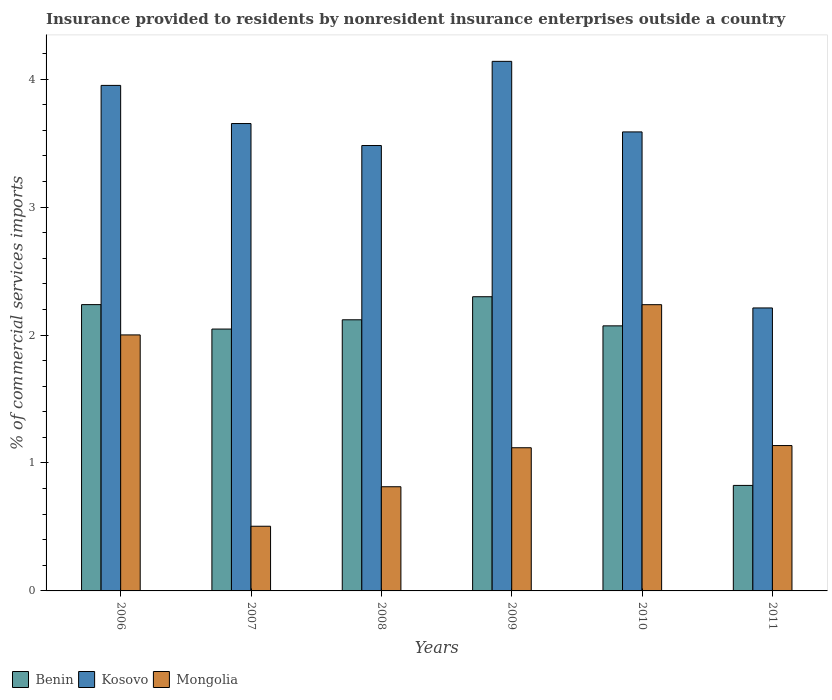Are the number of bars per tick equal to the number of legend labels?
Ensure brevity in your answer.  Yes. Are the number of bars on each tick of the X-axis equal?
Your answer should be compact. Yes. How many bars are there on the 1st tick from the left?
Your response must be concise. 3. What is the label of the 5th group of bars from the left?
Ensure brevity in your answer.  2010. What is the Insurance provided to residents in Benin in 2010?
Ensure brevity in your answer.  2.07. Across all years, what is the maximum Insurance provided to residents in Mongolia?
Offer a terse response. 2.24. Across all years, what is the minimum Insurance provided to residents in Kosovo?
Your response must be concise. 2.21. In which year was the Insurance provided to residents in Mongolia maximum?
Give a very brief answer. 2010. In which year was the Insurance provided to residents in Benin minimum?
Keep it short and to the point. 2011. What is the total Insurance provided to residents in Kosovo in the graph?
Your answer should be compact. 21.02. What is the difference between the Insurance provided to residents in Mongolia in 2007 and that in 2009?
Keep it short and to the point. -0.61. What is the difference between the Insurance provided to residents in Benin in 2011 and the Insurance provided to residents in Mongolia in 2006?
Ensure brevity in your answer.  -1.18. What is the average Insurance provided to residents in Kosovo per year?
Provide a succinct answer. 3.5. In the year 2006, what is the difference between the Insurance provided to residents in Kosovo and Insurance provided to residents in Benin?
Provide a succinct answer. 1.71. What is the ratio of the Insurance provided to residents in Kosovo in 2006 to that in 2009?
Offer a terse response. 0.95. Is the Insurance provided to residents in Kosovo in 2009 less than that in 2011?
Your response must be concise. No. What is the difference between the highest and the second highest Insurance provided to residents in Benin?
Provide a short and direct response. 0.06. What is the difference between the highest and the lowest Insurance provided to residents in Kosovo?
Give a very brief answer. 1.93. Is the sum of the Insurance provided to residents in Kosovo in 2007 and 2009 greater than the maximum Insurance provided to residents in Benin across all years?
Give a very brief answer. Yes. What does the 2nd bar from the left in 2009 represents?
Your response must be concise. Kosovo. What does the 3rd bar from the right in 2008 represents?
Provide a succinct answer. Benin. Is it the case that in every year, the sum of the Insurance provided to residents in Kosovo and Insurance provided to residents in Mongolia is greater than the Insurance provided to residents in Benin?
Provide a short and direct response. Yes. How many years are there in the graph?
Your response must be concise. 6. Are the values on the major ticks of Y-axis written in scientific E-notation?
Provide a short and direct response. No. Where does the legend appear in the graph?
Offer a very short reply. Bottom left. How many legend labels are there?
Give a very brief answer. 3. What is the title of the graph?
Make the answer very short. Insurance provided to residents by nonresident insurance enterprises outside a country. What is the label or title of the Y-axis?
Your answer should be compact. % of commercial services imports. What is the % of commercial services imports of Benin in 2006?
Offer a terse response. 2.24. What is the % of commercial services imports of Kosovo in 2006?
Give a very brief answer. 3.95. What is the % of commercial services imports in Mongolia in 2006?
Ensure brevity in your answer.  2. What is the % of commercial services imports of Benin in 2007?
Your answer should be very brief. 2.05. What is the % of commercial services imports of Kosovo in 2007?
Offer a very short reply. 3.65. What is the % of commercial services imports in Mongolia in 2007?
Offer a terse response. 0.51. What is the % of commercial services imports of Benin in 2008?
Your answer should be compact. 2.12. What is the % of commercial services imports in Kosovo in 2008?
Make the answer very short. 3.48. What is the % of commercial services imports in Mongolia in 2008?
Your answer should be compact. 0.81. What is the % of commercial services imports of Benin in 2009?
Your answer should be very brief. 2.3. What is the % of commercial services imports of Kosovo in 2009?
Make the answer very short. 4.14. What is the % of commercial services imports in Mongolia in 2009?
Provide a succinct answer. 1.12. What is the % of commercial services imports in Benin in 2010?
Your answer should be very brief. 2.07. What is the % of commercial services imports of Kosovo in 2010?
Offer a terse response. 3.59. What is the % of commercial services imports of Mongolia in 2010?
Your answer should be very brief. 2.24. What is the % of commercial services imports of Benin in 2011?
Provide a succinct answer. 0.82. What is the % of commercial services imports in Kosovo in 2011?
Your response must be concise. 2.21. What is the % of commercial services imports in Mongolia in 2011?
Provide a succinct answer. 1.14. Across all years, what is the maximum % of commercial services imports in Benin?
Your response must be concise. 2.3. Across all years, what is the maximum % of commercial services imports in Kosovo?
Your answer should be compact. 4.14. Across all years, what is the maximum % of commercial services imports in Mongolia?
Your answer should be compact. 2.24. Across all years, what is the minimum % of commercial services imports in Benin?
Your answer should be compact. 0.82. Across all years, what is the minimum % of commercial services imports of Kosovo?
Keep it short and to the point. 2.21. Across all years, what is the minimum % of commercial services imports in Mongolia?
Offer a very short reply. 0.51. What is the total % of commercial services imports of Benin in the graph?
Provide a succinct answer. 11.6. What is the total % of commercial services imports in Kosovo in the graph?
Your answer should be very brief. 21.02. What is the total % of commercial services imports of Mongolia in the graph?
Provide a short and direct response. 7.81. What is the difference between the % of commercial services imports of Benin in 2006 and that in 2007?
Ensure brevity in your answer.  0.19. What is the difference between the % of commercial services imports of Kosovo in 2006 and that in 2007?
Ensure brevity in your answer.  0.3. What is the difference between the % of commercial services imports in Mongolia in 2006 and that in 2007?
Provide a succinct answer. 1.5. What is the difference between the % of commercial services imports in Benin in 2006 and that in 2008?
Keep it short and to the point. 0.12. What is the difference between the % of commercial services imports of Kosovo in 2006 and that in 2008?
Your response must be concise. 0.47. What is the difference between the % of commercial services imports in Mongolia in 2006 and that in 2008?
Offer a very short reply. 1.19. What is the difference between the % of commercial services imports of Benin in 2006 and that in 2009?
Offer a very short reply. -0.06. What is the difference between the % of commercial services imports in Kosovo in 2006 and that in 2009?
Offer a terse response. -0.19. What is the difference between the % of commercial services imports in Mongolia in 2006 and that in 2009?
Give a very brief answer. 0.88. What is the difference between the % of commercial services imports in Benin in 2006 and that in 2010?
Make the answer very short. 0.17. What is the difference between the % of commercial services imports in Kosovo in 2006 and that in 2010?
Make the answer very short. 0.36. What is the difference between the % of commercial services imports of Mongolia in 2006 and that in 2010?
Provide a succinct answer. -0.24. What is the difference between the % of commercial services imports of Benin in 2006 and that in 2011?
Make the answer very short. 1.41. What is the difference between the % of commercial services imports of Kosovo in 2006 and that in 2011?
Your answer should be very brief. 1.74. What is the difference between the % of commercial services imports of Mongolia in 2006 and that in 2011?
Your answer should be very brief. 0.86. What is the difference between the % of commercial services imports in Benin in 2007 and that in 2008?
Offer a very short reply. -0.07. What is the difference between the % of commercial services imports in Kosovo in 2007 and that in 2008?
Your answer should be very brief. 0.17. What is the difference between the % of commercial services imports in Mongolia in 2007 and that in 2008?
Ensure brevity in your answer.  -0.31. What is the difference between the % of commercial services imports of Benin in 2007 and that in 2009?
Your answer should be very brief. -0.25. What is the difference between the % of commercial services imports in Kosovo in 2007 and that in 2009?
Provide a short and direct response. -0.49. What is the difference between the % of commercial services imports in Mongolia in 2007 and that in 2009?
Your answer should be very brief. -0.61. What is the difference between the % of commercial services imports of Benin in 2007 and that in 2010?
Offer a terse response. -0.03. What is the difference between the % of commercial services imports of Kosovo in 2007 and that in 2010?
Provide a short and direct response. 0.07. What is the difference between the % of commercial services imports of Mongolia in 2007 and that in 2010?
Offer a terse response. -1.73. What is the difference between the % of commercial services imports in Benin in 2007 and that in 2011?
Provide a succinct answer. 1.22. What is the difference between the % of commercial services imports in Kosovo in 2007 and that in 2011?
Keep it short and to the point. 1.44. What is the difference between the % of commercial services imports in Mongolia in 2007 and that in 2011?
Ensure brevity in your answer.  -0.63. What is the difference between the % of commercial services imports in Benin in 2008 and that in 2009?
Your response must be concise. -0.18. What is the difference between the % of commercial services imports in Kosovo in 2008 and that in 2009?
Provide a short and direct response. -0.66. What is the difference between the % of commercial services imports of Mongolia in 2008 and that in 2009?
Offer a terse response. -0.3. What is the difference between the % of commercial services imports of Benin in 2008 and that in 2010?
Offer a very short reply. 0.05. What is the difference between the % of commercial services imports in Kosovo in 2008 and that in 2010?
Ensure brevity in your answer.  -0.11. What is the difference between the % of commercial services imports in Mongolia in 2008 and that in 2010?
Offer a terse response. -1.42. What is the difference between the % of commercial services imports in Benin in 2008 and that in 2011?
Your answer should be very brief. 1.29. What is the difference between the % of commercial services imports of Kosovo in 2008 and that in 2011?
Offer a terse response. 1.27. What is the difference between the % of commercial services imports of Mongolia in 2008 and that in 2011?
Provide a succinct answer. -0.32. What is the difference between the % of commercial services imports in Benin in 2009 and that in 2010?
Keep it short and to the point. 0.23. What is the difference between the % of commercial services imports of Kosovo in 2009 and that in 2010?
Your answer should be very brief. 0.55. What is the difference between the % of commercial services imports of Mongolia in 2009 and that in 2010?
Provide a succinct answer. -1.12. What is the difference between the % of commercial services imports in Benin in 2009 and that in 2011?
Keep it short and to the point. 1.47. What is the difference between the % of commercial services imports of Kosovo in 2009 and that in 2011?
Ensure brevity in your answer.  1.93. What is the difference between the % of commercial services imports of Mongolia in 2009 and that in 2011?
Your answer should be very brief. -0.02. What is the difference between the % of commercial services imports of Benin in 2010 and that in 2011?
Your response must be concise. 1.25. What is the difference between the % of commercial services imports of Kosovo in 2010 and that in 2011?
Keep it short and to the point. 1.38. What is the difference between the % of commercial services imports of Mongolia in 2010 and that in 2011?
Your answer should be very brief. 1.1. What is the difference between the % of commercial services imports in Benin in 2006 and the % of commercial services imports in Kosovo in 2007?
Keep it short and to the point. -1.42. What is the difference between the % of commercial services imports of Benin in 2006 and the % of commercial services imports of Mongolia in 2007?
Make the answer very short. 1.73. What is the difference between the % of commercial services imports of Kosovo in 2006 and the % of commercial services imports of Mongolia in 2007?
Make the answer very short. 3.45. What is the difference between the % of commercial services imports of Benin in 2006 and the % of commercial services imports of Kosovo in 2008?
Provide a short and direct response. -1.24. What is the difference between the % of commercial services imports of Benin in 2006 and the % of commercial services imports of Mongolia in 2008?
Offer a very short reply. 1.42. What is the difference between the % of commercial services imports in Kosovo in 2006 and the % of commercial services imports in Mongolia in 2008?
Your answer should be compact. 3.14. What is the difference between the % of commercial services imports of Benin in 2006 and the % of commercial services imports of Kosovo in 2009?
Provide a short and direct response. -1.9. What is the difference between the % of commercial services imports of Benin in 2006 and the % of commercial services imports of Mongolia in 2009?
Make the answer very short. 1.12. What is the difference between the % of commercial services imports in Kosovo in 2006 and the % of commercial services imports in Mongolia in 2009?
Ensure brevity in your answer.  2.83. What is the difference between the % of commercial services imports in Benin in 2006 and the % of commercial services imports in Kosovo in 2010?
Give a very brief answer. -1.35. What is the difference between the % of commercial services imports of Kosovo in 2006 and the % of commercial services imports of Mongolia in 2010?
Your answer should be very brief. 1.71. What is the difference between the % of commercial services imports in Benin in 2006 and the % of commercial services imports in Kosovo in 2011?
Make the answer very short. 0.03. What is the difference between the % of commercial services imports of Benin in 2006 and the % of commercial services imports of Mongolia in 2011?
Your answer should be very brief. 1.1. What is the difference between the % of commercial services imports of Kosovo in 2006 and the % of commercial services imports of Mongolia in 2011?
Give a very brief answer. 2.82. What is the difference between the % of commercial services imports in Benin in 2007 and the % of commercial services imports in Kosovo in 2008?
Provide a short and direct response. -1.43. What is the difference between the % of commercial services imports of Benin in 2007 and the % of commercial services imports of Mongolia in 2008?
Provide a succinct answer. 1.23. What is the difference between the % of commercial services imports of Kosovo in 2007 and the % of commercial services imports of Mongolia in 2008?
Give a very brief answer. 2.84. What is the difference between the % of commercial services imports in Benin in 2007 and the % of commercial services imports in Kosovo in 2009?
Ensure brevity in your answer.  -2.09. What is the difference between the % of commercial services imports in Benin in 2007 and the % of commercial services imports in Mongolia in 2009?
Ensure brevity in your answer.  0.93. What is the difference between the % of commercial services imports in Kosovo in 2007 and the % of commercial services imports in Mongolia in 2009?
Give a very brief answer. 2.53. What is the difference between the % of commercial services imports of Benin in 2007 and the % of commercial services imports of Kosovo in 2010?
Keep it short and to the point. -1.54. What is the difference between the % of commercial services imports of Benin in 2007 and the % of commercial services imports of Mongolia in 2010?
Offer a terse response. -0.19. What is the difference between the % of commercial services imports in Kosovo in 2007 and the % of commercial services imports in Mongolia in 2010?
Give a very brief answer. 1.42. What is the difference between the % of commercial services imports in Benin in 2007 and the % of commercial services imports in Kosovo in 2011?
Give a very brief answer. -0.17. What is the difference between the % of commercial services imports of Benin in 2007 and the % of commercial services imports of Mongolia in 2011?
Ensure brevity in your answer.  0.91. What is the difference between the % of commercial services imports of Kosovo in 2007 and the % of commercial services imports of Mongolia in 2011?
Ensure brevity in your answer.  2.52. What is the difference between the % of commercial services imports in Benin in 2008 and the % of commercial services imports in Kosovo in 2009?
Keep it short and to the point. -2.02. What is the difference between the % of commercial services imports in Benin in 2008 and the % of commercial services imports in Mongolia in 2009?
Provide a succinct answer. 1. What is the difference between the % of commercial services imports in Kosovo in 2008 and the % of commercial services imports in Mongolia in 2009?
Ensure brevity in your answer.  2.36. What is the difference between the % of commercial services imports in Benin in 2008 and the % of commercial services imports in Kosovo in 2010?
Offer a very short reply. -1.47. What is the difference between the % of commercial services imports of Benin in 2008 and the % of commercial services imports of Mongolia in 2010?
Your response must be concise. -0.12. What is the difference between the % of commercial services imports of Kosovo in 2008 and the % of commercial services imports of Mongolia in 2010?
Your answer should be compact. 1.24. What is the difference between the % of commercial services imports of Benin in 2008 and the % of commercial services imports of Kosovo in 2011?
Provide a short and direct response. -0.09. What is the difference between the % of commercial services imports in Kosovo in 2008 and the % of commercial services imports in Mongolia in 2011?
Your answer should be compact. 2.35. What is the difference between the % of commercial services imports in Benin in 2009 and the % of commercial services imports in Kosovo in 2010?
Provide a succinct answer. -1.29. What is the difference between the % of commercial services imports of Benin in 2009 and the % of commercial services imports of Mongolia in 2010?
Ensure brevity in your answer.  0.06. What is the difference between the % of commercial services imports of Kosovo in 2009 and the % of commercial services imports of Mongolia in 2010?
Ensure brevity in your answer.  1.9. What is the difference between the % of commercial services imports in Benin in 2009 and the % of commercial services imports in Kosovo in 2011?
Offer a terse response. 0.09. What is the difference between the % of commercial services imports in Benin in 2009 and the % of commercial services imports in Mongolia in 2011?
Make the answer very short. 1.16. What is the difference between the % of commercial services imports of Kosovo in 2009 and the % of commercial services imports of Mongolia in 2011?
Make the answer very short. 3. What is the difference between the % of commercial services imports of Benin in 2010 and the % of commercial services imports of Kosovo in 2011?
Keep it short and to the point. -0.14. What is the difference between the % of commercial services imports of Benin in 2010 and the % of commercial services imports of Mongolia in 2011?
Provide a succinct answer. 0.94. What is the difference between the % of commercial services imports in Kosovo in 2010 and the % of commercial services imports in Mongolia in 2011?
Make the answer very short. 2.45. What is the average % of commercial services imports of Benin per year?
Your response must be concise. 1.93. What is the average % of commercial services imports of Kosovo per year?
Your response must be concise. 3.5. What is the average % of commercial services imports in Mongolia per year?
Provide a short and direct response. 1.3. In the year 2006, what is the difference between the % of commercial services imports in Benin and % of commercial services imports in Kosovo?
Provide a succinct answer. -1.71. In the year 2006, what is the difference between the % of commercial services imports in Benin and % of commercial services imports in Mongolia?
Offer a very short reply. 0.24. In the year 2006, what is the difference between the % of commercial services imports of Kosovo and % of commercial services imports of Mongolia?
Keep it short and to the point. 1.95. In the year 2007, what is the difference between the % of commercial services imports in Benin and % of commercial services imports in Kosovo?
Give a very brief answer. -1.61. In the year 2007, what is the difference between the % of commercial services imports of Benin and % of commercial services imports of Mongolia?
Your response must be concise. 1.54. In the year 2007, what is the difference between the % of commercial services imports in Kosovo and % of commercial services imports in Mongolia?
Offer a terse response. 3.15. In the year 2008, what is the difference between the % of commercial services imports of Benin and % of commercial services imports of Kosovo?
Provide a short and direct response. -1.36. In the year 2008, what is the difference between the % of commercial services imports in Benin and % of commercial services imports in Mongolia?
Your answer should be compact. 1.31. In the year 2008, what is the difference between the % of commercial services imports of Kosovo and % of commercial services imports of Mongolia?
Your answer should be very brief. 2.67. In the year 2009, what is the difference between the % of commercial services imports of Benin and % of commercial services imports of Kosovo?
Provide a succinct answer. -1.84. In the year 2009, what is the difference between the % of commercial services imports of Benin and % of commercial services imports of Mongolia?
Make the answer very short. 1.18. In the year 2009, what is the difference between the % of commercial services imports of Kosovo and % of commercial services imports of Mongolia?
Offer a very short reply. 3.02. In the year 2010, what is the difference between the % of commercial services imports in Benin and % of commercial services imports in Kosovo?
Your response must be concise. -1.52. In the year 2010, what is the difference between the % of commercial services imports of Benin and % of commercial services imports of Mongolia?
Provide a succinct answer. -0.17. In the year 2010, what is the difference between the % of commercial services imports in Kosovo and % of commercial services imports in Mongolia?
Provide a short and direct response. 1.35. In the year 2011, what is the difference between the % of commercial services imports of Benin and % of commercial services imports of Kosovo?
Make the answer very short. -1.39. In the year 2011, what is the difference between the % of commercial services imports in Benin and % of commercial services imports in Mongolia?
Offer a terse response. -0.31. In the year 2011, what is the difference between the % of commercial services imports of Kosovo and % of commercial services imports of Mongolia?
Offer a terse response. 1.08. What is the ratio of the % of commercial services imports of Benin in 2006 to that in 2007?
Your response must be concise. 1.09. What is the ratio of the % of commercial services imports in Kosovo in 2006 to that in 2007?
Provide a short and direct response. 1.08. What is the ratio of the % of commercial services imports of Mongolia in 2006 to that in 2007?
Ensure brevity in your answer.  3.96. What is the ratio of the % of commercial services imports in Benin in 2006 to that in 2008?
Your answer should be compact. 1.06. What is the ratio of the % of commercial services imports of Kosovo in 2006 to that in 2008?
Keep it short and to the point. 1.14. What is the ratio of the % of commercial services imports of Mongolia in 2006 to that in 2008?
Keep it short and to the point. 2.46. What is the ratio of the % of commercial services imports of Benin in 2006 to that in 2009?
Your answer should be very brief. 0.97. What is the ratio of the % of commercial services imports in Kosovo in 2006 to that in 2009?
Your answer should be compact. 0.95. What is the ratio of the % of commercial services imports of Mongolia in 2006 to that in 2009?
Your answer should be compact. 1.79. What is the ratio of the % of commercial services imports of Benin in 2006 to that in 2010?
Keep it short and to the point. 1.08. What is the ratio of the % of commercial services imports in Kosovo in 2006 to that in 2010?
Provide a succinct answer. 1.1. What is the ratio of the % of commercial services imports in Mongolia in 2006 to that in 2010?
Your response must be concise. 0.89. What is the ratio of the % of commercial services imports of Benin in 2006 to that in 2011?
Offer a terse response. 2.71. What is the ratio of the % of commercial services imports of Kosovo in 2006 to that in 2011?
Keep it short and to the point. 1.79. What is the ratio of the % of commercial services imports of Mongolia in 2006 to that in 2011?
Give a very brief answer. 1.76. What is the ratio of the % of commercial services imports in Benin in 2007 to that in 2008?
Offer a terse response. 0.97. What is the ratio of the % of commercial services imports of Kosovo in 2007 to that in 2008?
Offer a very short reply. 1.05. What is the ratio of the % of commercial services imports in Mongolia in 2007 to that in 2008?
Your answer should be very brief. 0.62. What is the ratio of the % of commercial services imports of Benin in 2007 to that in 2009?
Ensure brevity in your answer.  0.89. What is the ratio of the % of commercial services imports of Kosovo in 2007 to that in 2009?
Give a very brief answer. 0.88. What is the ratio of the % of commercial services imports in Mongolia in 2007 to that in 2009?
Offer a terse response. 0.45. What is the ratio of the % of commercial services imports in Benin in 2007 to that in 2010?
Ensure brevity in your answer.  0.99. What is the ratio of the % of commercial services imports in Kosovo in 2007 to that in 2010?
Your answer should be compact. 1.02. What is the ratio of the % of commercial services imports of Mongolia in 2007 to that in 2010?
Your answer should be very brief. 0.23. What is the ratio of the % of commercial services imports in Benin in 2007 to that in 2011?
Provide a succinct answer. 2.48. What is the ratio of the % of commercial services imports in Kosovo in 2007 to that in 2011?
Provide a succinct answer. 1.65. What is the ratio of the % of commercial services imports of Mongolia in 2007 to that in 2011?
Offer a very short reply. 0.44. What is the ratio of the % of commercial services imports of Benin in 2008 to that in 2009?
Keep it short and to the point. 0.92. What is the ratio of the % of commercial services imports in Kosovo in 2008 to that in 2009?
Offer a terse response. 0.84. What is the ratio of the % of commercial services imports in Mongolia in 2008 to that in 2009?
Provide a short and direct response. 0.73. What is the ratio of the % of commercial services imports of Benin in 2008 to that in 2010?
Keep it short and to the point. 1.02. What is the ratio of the % of commercial services imports of Kosovo in 2008 to that in 2010?
Provide a short and direct response. 0.97. What is the ratio of the % of commercial services imports of Mongolia in 2008 to that in 2010?
Ensure brevity in your answer.  0.36. What is the ratio of the % of commercial services imports of Benin in 2008 to that in 2011?
Ensure brevity in your answer.  2.57. What is the ratio of the % of commercial services imports in Kosovo in 2008 to that in 2011?
Your response must be concise. 1.57. What is the ratio of the % of commercial services imports in Mongolia in 2008 to that in 2011?
Provide a short and direct response. 0.72. What is the ratio of the % of commercial services imports in Benin in 2009 to that in 2010?
Provide a short and direct response. 1.11. What is the ratio of the % of commercial services imports of Kosovo in 2009 to that in 2010?
Your answer should be compact. 1.15. What is the ratio of the % of commercial services imports of Mongolia in 2009 to that in 2010?
Keep it short and to the point. 0.5. What is the ratio of the % of commercial services imports of Benin in 2009 to that in 2011?
Ensure brevity in your answer.  2.79. What is the ratio of the % of commercial services imports of Kosovo in 2009 to that in 2011?
Ensure brevity in your answer.  1.87. What is the ratio of the % of commercial services imports in Mongolia in 2009 to that in 2011?
Ensure brevity in your answer.  0.98. What is the ratio of the % of commercial services imports of Benin in 2010 to that in 2011?
Offer a very short reply. 2.51. What is the ratio of the % of commercial services imports of Kosovo in 2010 to that in 2011?
Your answer should be very brief. 1.62. What is the ratio of the % of commercial services imports of Mongolia in 2010 to that in 2011?
Provide a short and direct response. 1.97. What is the difference between the highest and the second highest % of commercial services imports in Benin?
Give a very brief answer. 0.06. What is the difference between the highest and the second highest % of commercial services imports of Kosovo?
Ensure brevity in your answer.  0.19. What is the difference between the highest and the second highest % of commercial services imports in Mongolia?
Provide a short and direct response. 0.24. What is the difference between the highest and the lowest % of commercial services imports in Benin?
Offer a terse response. 1.47. What is the difference between the highest and the lowest % of commercial services imports in Kosovo?
Your answer should be very brief. 1.93. What is the difference between the highest and the lowest % of commercial services imports of Mongolia?
Ensure brevity in your answer.  1.73. 